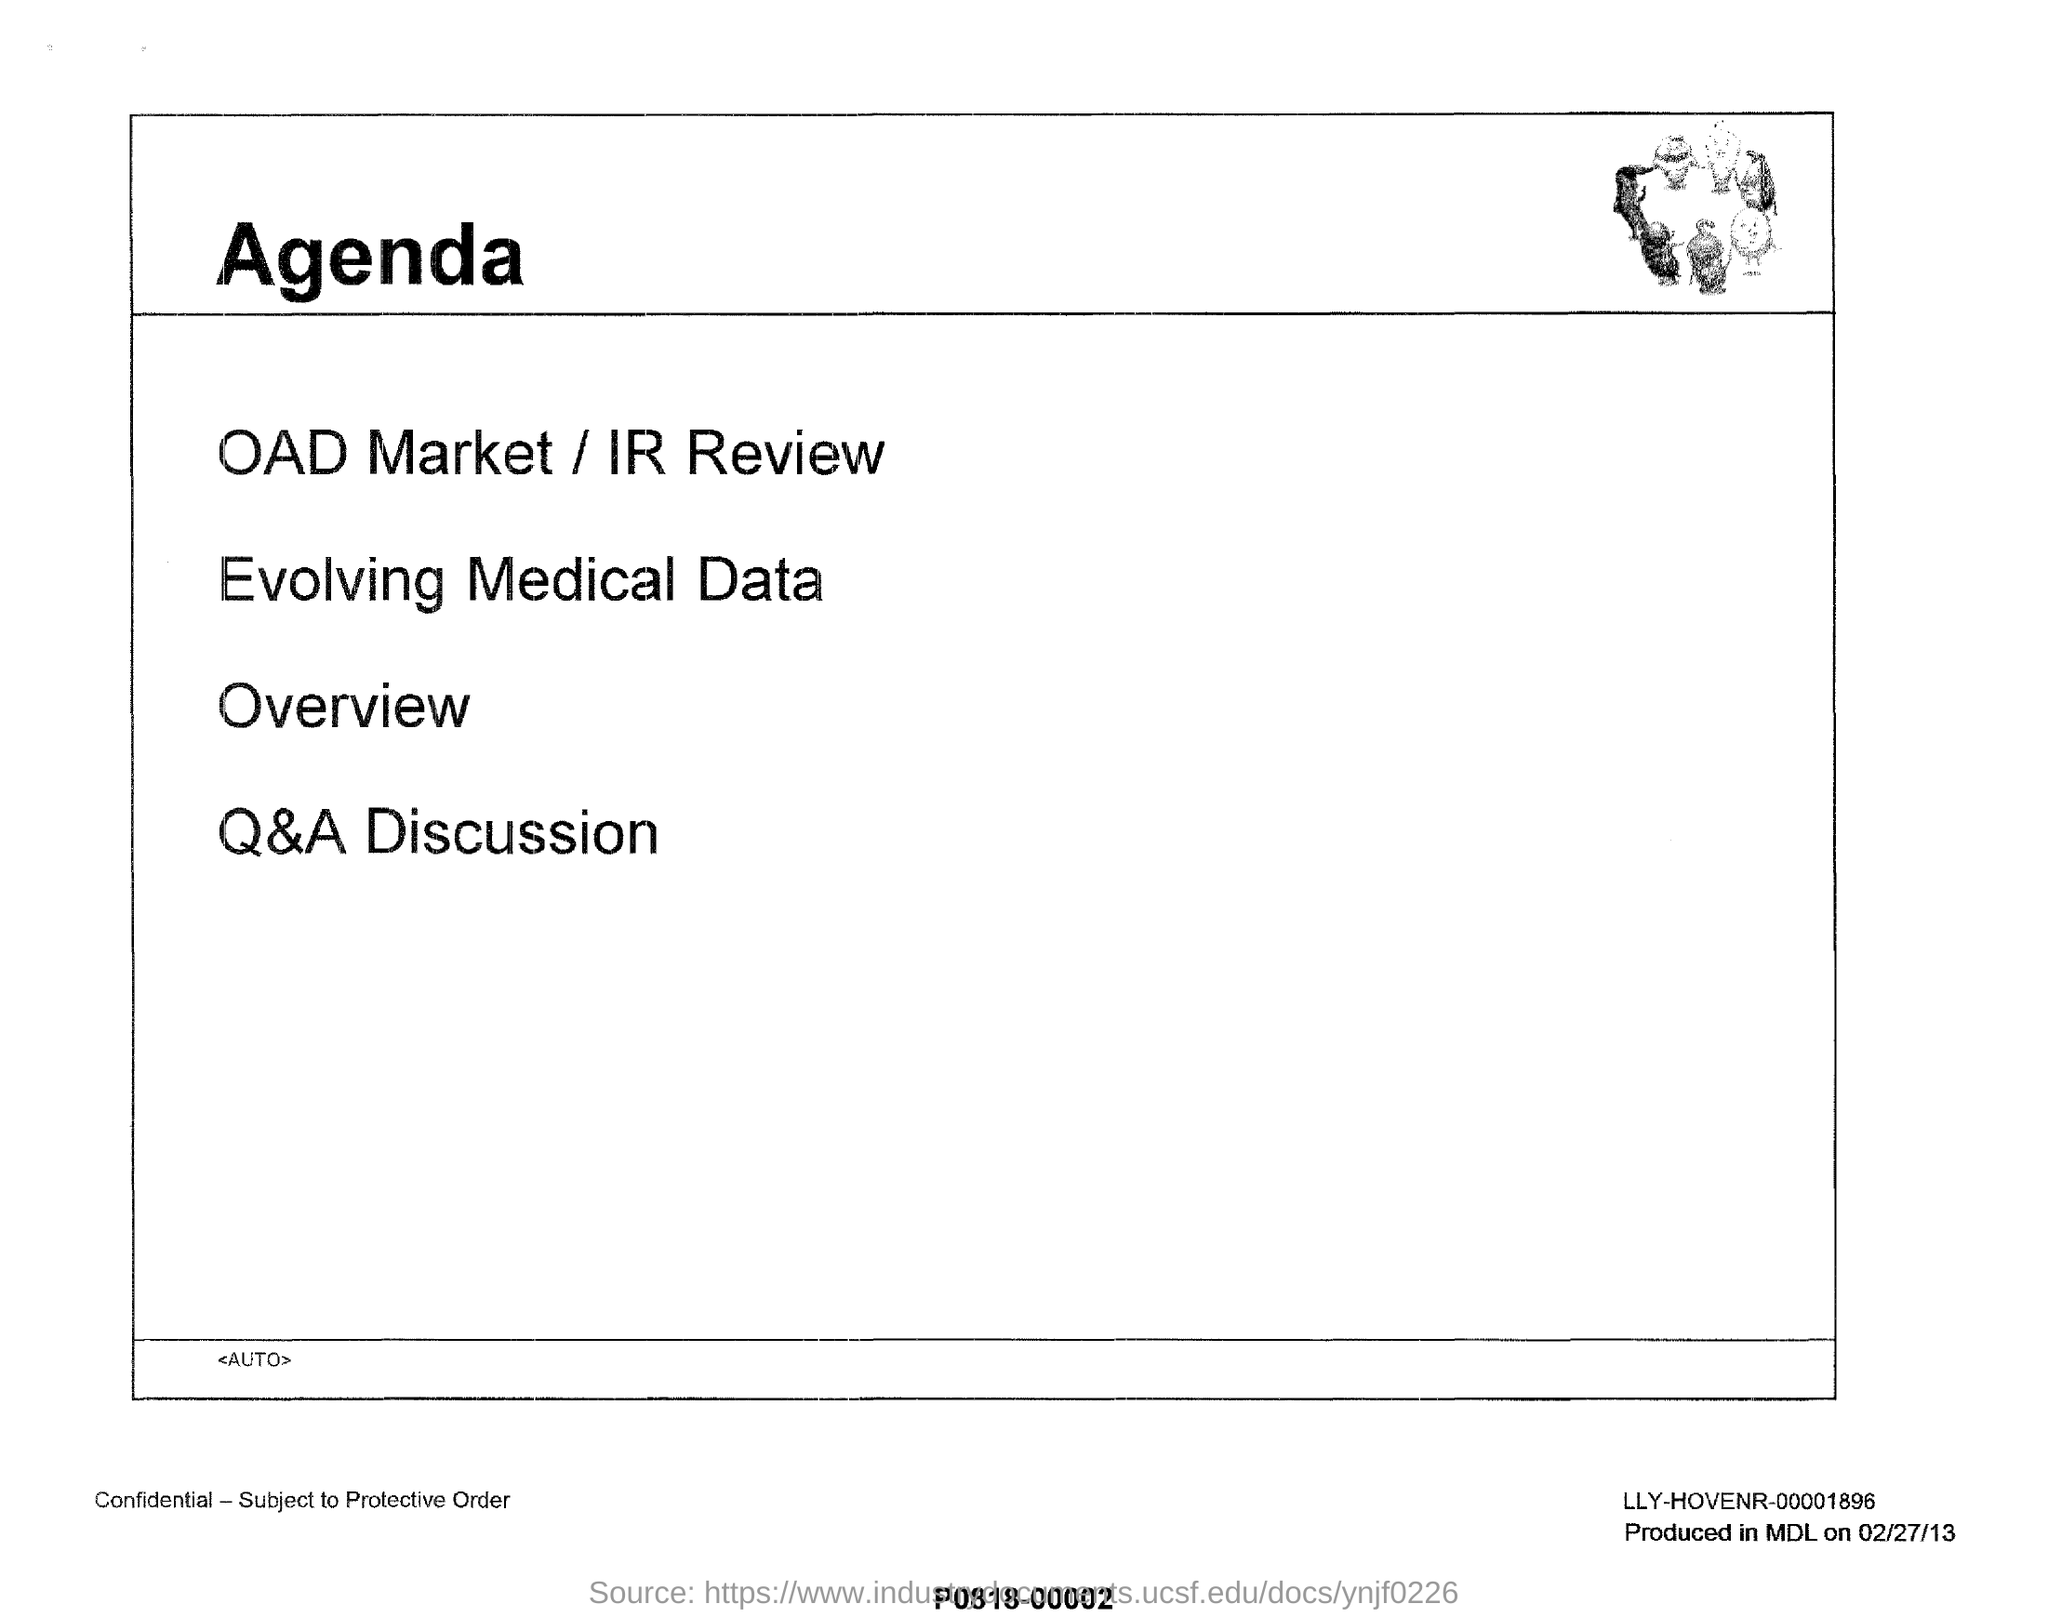What is the title of this document?
Offer a terse response. Agenda. What is listed first on the agenda?
Your answer should be compact. OAD Market / IR Review. What is listed last on the agenda?
Provide a succinct answer. Q&A Discussion. 